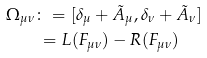Convert formula to latex. <formula><loc_0><loc_0><loc_500><loc_500>\Omega _ { \mu \nu } & \colon = [ \delta _ { \mu } + \tilde { A } _ { \mu } , \delta _ { \nu } + \tilde { A } _ { \nu } ] \\ & \, = L ( F _ { \mu \nu } ) - R ( F _ { \mu \nu } )</formula> 